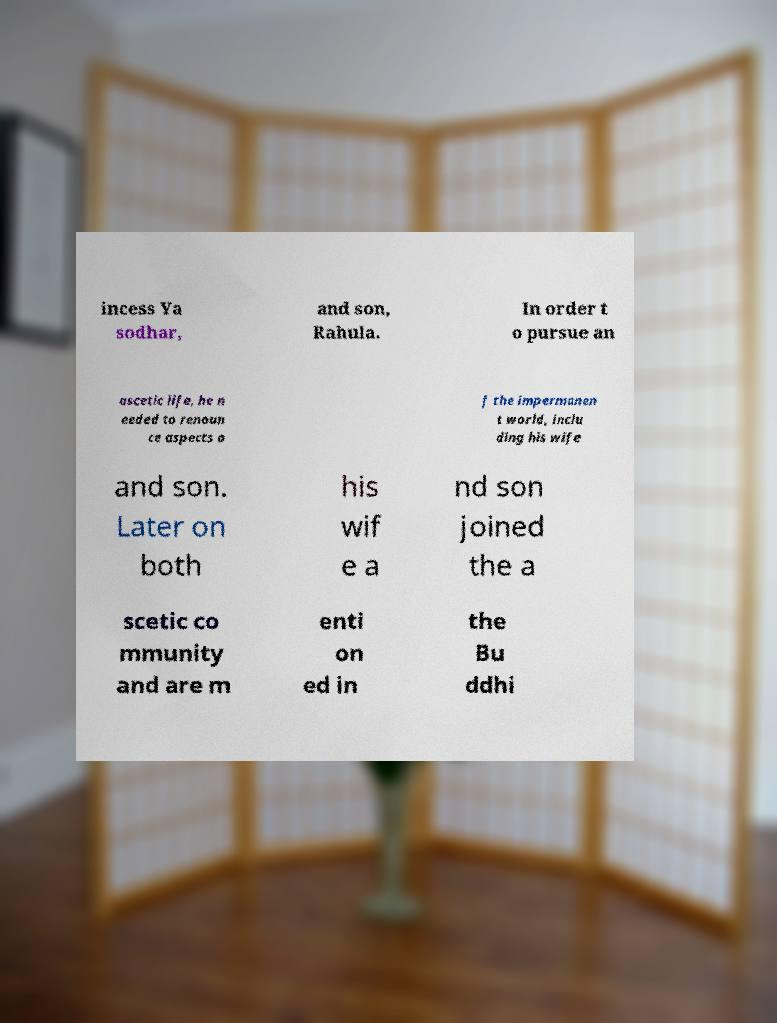What messages or text are displayed in this image? I need them in a readable, typed format. incess Ya sodhar, and son, Rahula. In order t o pursue an ascetic life, he n eeded to renoun ce aspects o f the impermanen t world, inclu ding his wife and son. Later on both his wif e a nd son joined the a scetic co mmunity and are m enti on ed in the Bu ddhi 